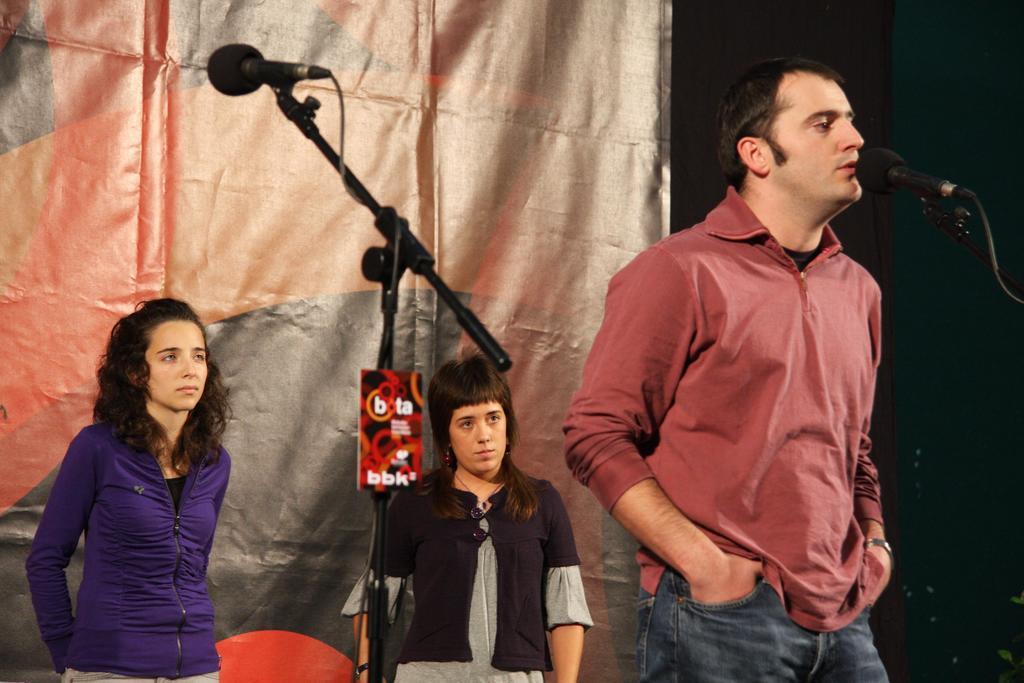How would you summarize this image in a sentence or two? In this picture we can see there are people standing on the stage and in front of the people there are microphones with stands. Behind the people there is a banner and other things. 